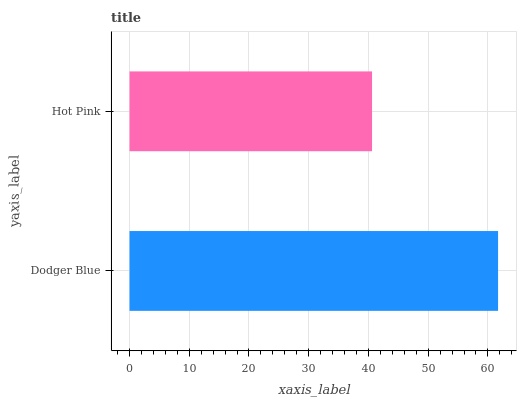Is Hot Pink the minimum?
Answer yes or no. Yes. Is Dodger Blue the maximum?
Answer yes or no. Yes. Is Hot Pink the maximum?
Answer yes or no. No. Is Dodger Blue greater than Hot Pink?
Answer yes or no. Yes. Is Hot Pink less than Dodger Blue?
Answer yes or no. Yes. Is Hot Pink greater than Dodger Blue?
Answer yes or no. No. Is Dodger Blue less than Hot Pink?
Answer yes or no. No. Is Dodger Blue the high median?
Answer yes or no. Yes. Is Hot Pink the low median?
Answer yes or no. Yes. Is Hot Pink the high median?
Answer yes or no. No. Is Dodger Blue the low median?
Answer yes or no. No. 